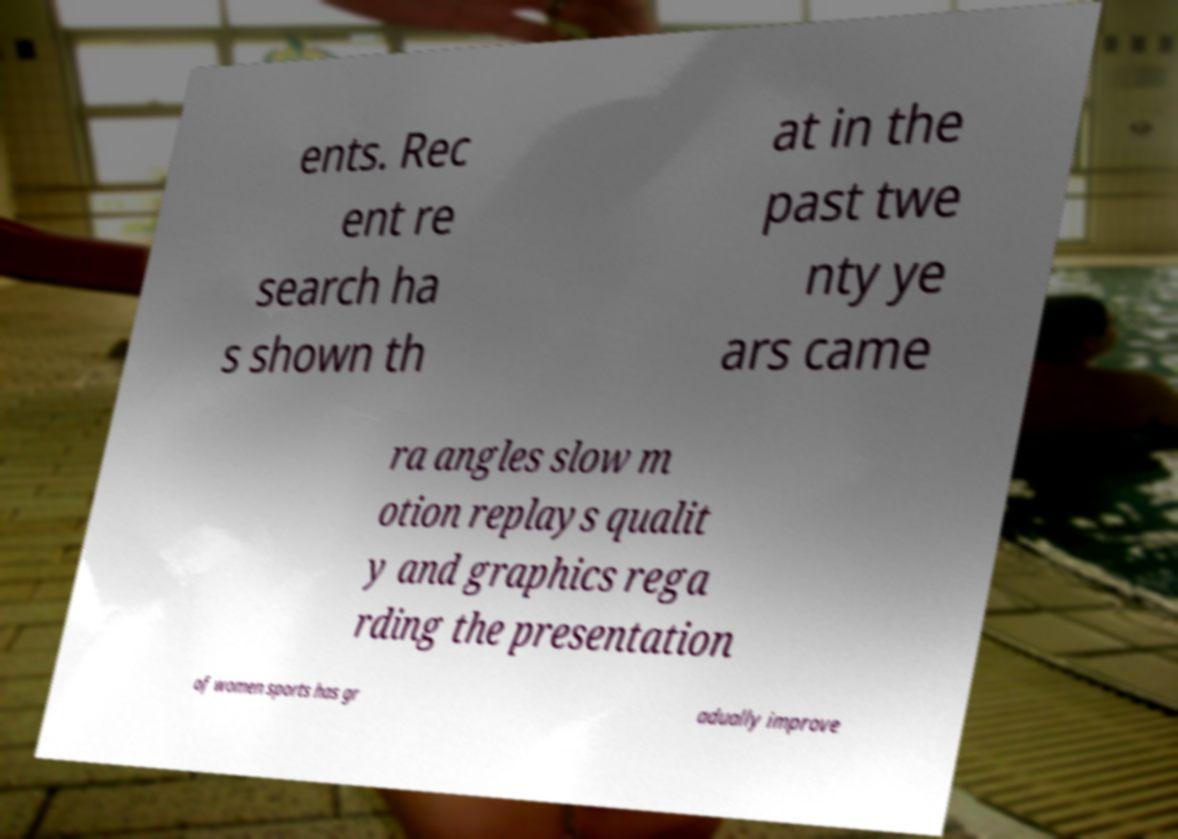Can you read and provide the text displayed in the image?This photo seems to have some interesting text. Can you extract and type it out for me? ents. Rec ent re search ha s shown th at in the past twe nty ye ars came ra angles slow m otion replays qualit y and graphics rega rding the presentation of women sports has gr adually improve 